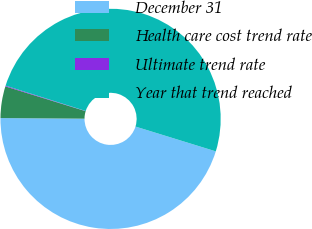Convert chart. <chart><loc_0><loc_0><loc_500><loc_500><pie_chart><fcel>December 31<fcel>Health care cost trend rate<fcel>Ultimate trend rate<fcel>Year that trend reached<nl><fcel>45.35%<fcel>4.65%<fcel>0.11%<fcel>49.89%<nl></chart> 